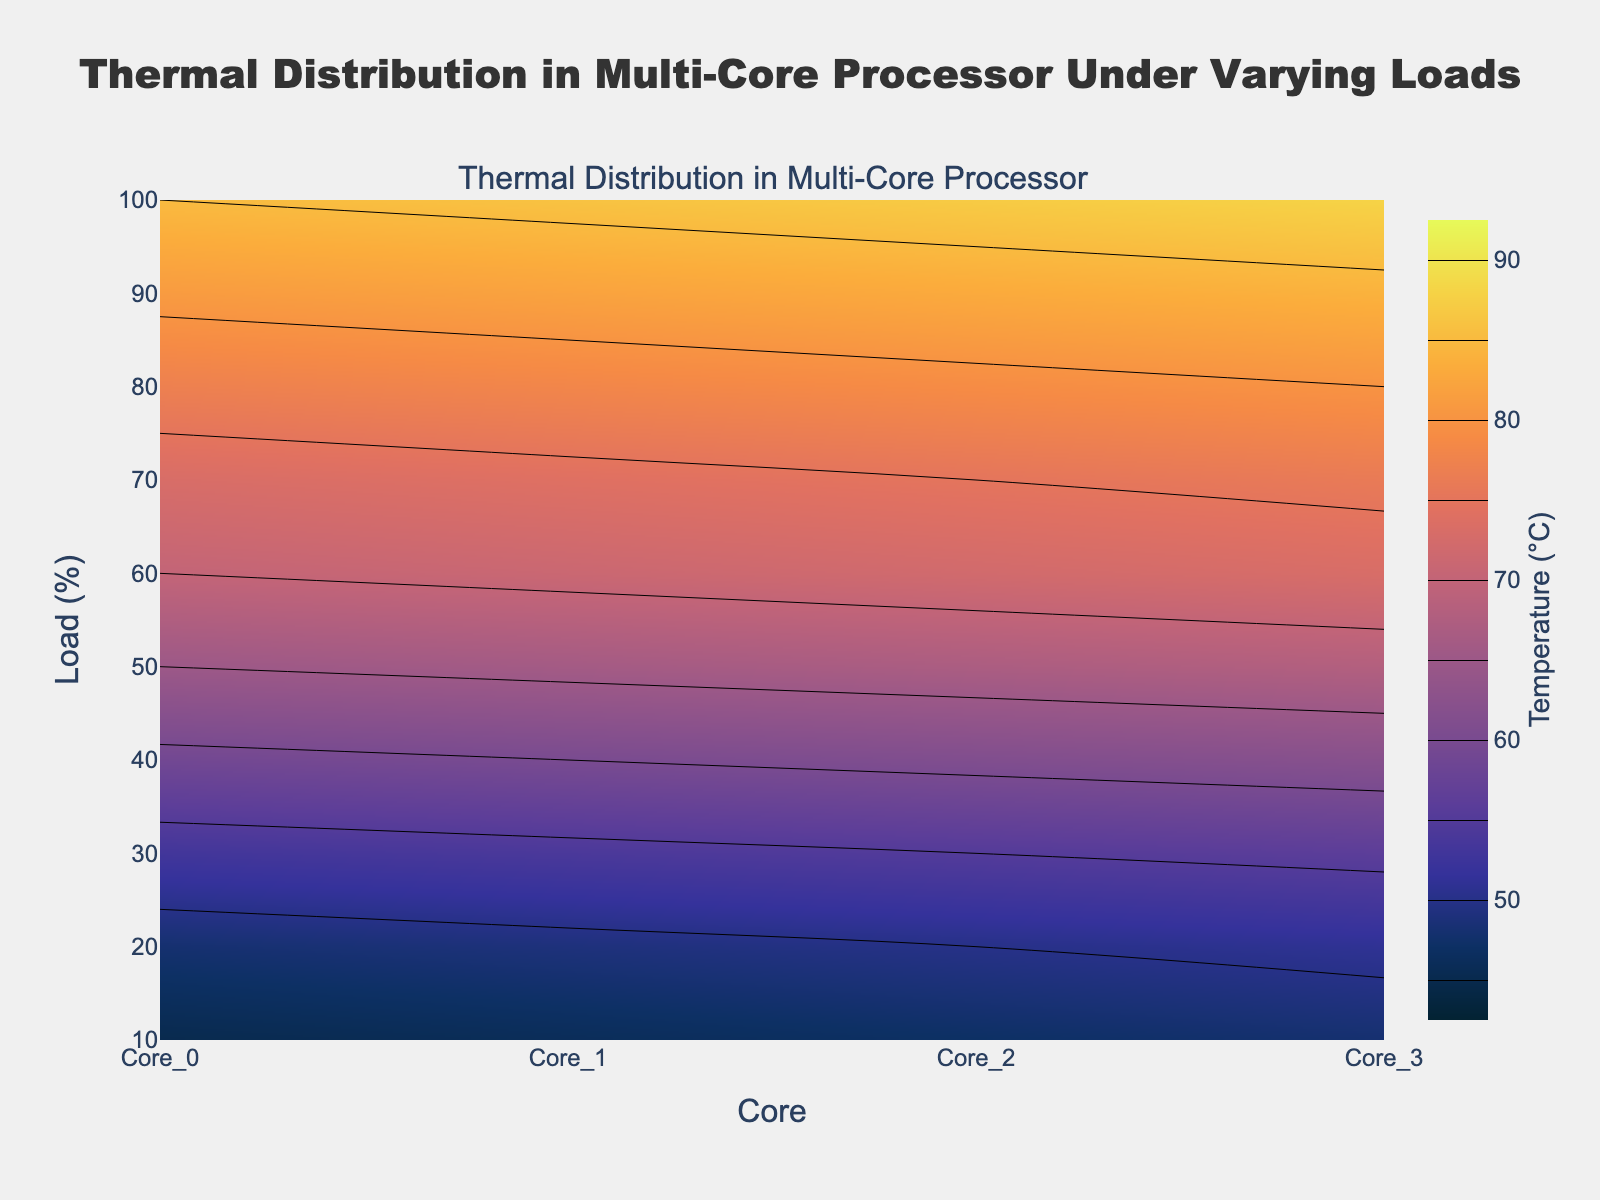What's the title of the figure? The title of a figure is usually displayed at the top and provides a brief description of what the figure is about. In this case, the title is "Thermal Distribution in Multi-Core Processor Under Varying Loads".
Answer: Thermal Distribution in Multi-Core Processor Under Varying Loads What units are used for the temperature axis? The color bar on the right-hand side of the plot usually indicates the units for the temperature. The title of the color bar in the figure reads "Temperature (°C)".
Answer: °C Which core has the highest temperature at 100% load? To determine which core has the highest temperature at 100% load, we look at the values for the temperature at the 100% load level for all the cores. Core 3 has the highest temperature at 88°C.
Answer: Core 3 At what load level does Core 0 reach a temperature of 70°C? To find out at what load Core 0 reaches 70°C, we can hover over the contour plot or check the provided temperature data. The temperature of Core 0 is 70°C at a load of 60%.
Answer: 60% How does the temperature change from Core 0 to Core 3 at 40% load? To see how the temperature changes from Core 0 to Core 3 at 40% load, look at the temperatures for each core at that load level: Core 0 (59°C), Core 1 (60°C), Core 2 (61°C), and Core 3 (62°C). The temperature increases by 1°C from each core to the next.
Answer: Increases by 1°C per core Calculate the average temperature for Core 1 across all load levels. To determine the average temperature for Core 1, sum all temperatures for Core 1 (46 + 49 + 54 + 60 + 66 + 71 + 74 + 78 + 82 + 86 = 666) and divide by the number of data points (10): 666 / 10 = 66.6°C.
Answer: 66.6°C Which load level shows the most significant temperature difference between Core 0 and Core 2? To find this, calculate the absolute temperature differences between Core 0 and Core 2 at each load level, then identify the highest difference. The differences are 2, 2, 2, 2, 2, 2, 2, 2, 2, and 2, indicating that the difference is consistent across all load levels.
Answer: The difference is consistent (2°C) across all load levels Are there any load levels where all cores have the same temperature? By reviewing the data, we see there are no load levels where all cores have the same temperature; all temperatures differ by at least 1°C at each load level.
Answer: No What is the temperature range for Core 2 across the load levels? The temperature range is found by subtracting the minimum temperature from the maximum temperature for Core 2. The temperatures range from 47°C to 87°C, so the range is 87°C - 47°C = 40°C.
Answer: 40°C 